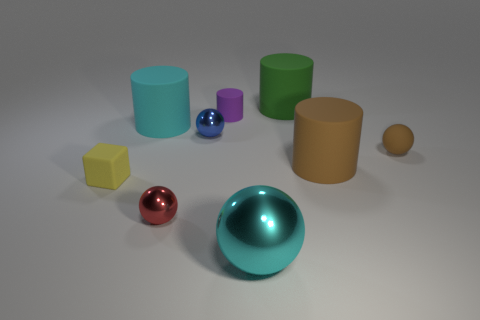Subtract 1 balls. How many balls are left? 3 Subtract all green cylinders. Subtract all yellow blocks. How many cylinders are left? 3 Add 1 tiny blue metal balls. How many objects exist? 10 Subtract all cubes. How many objects are left? 8 Subtract 0 cyan cubes. How many objects are left? 9 Subtract all tiny rubber objects. Subtract all small purple cylinders. How many objects are left? 5 Add 1 small yellow objects. How many small yellow objects are left? 2 Add 3 small green blocks. How many small green blocks exist? 3 